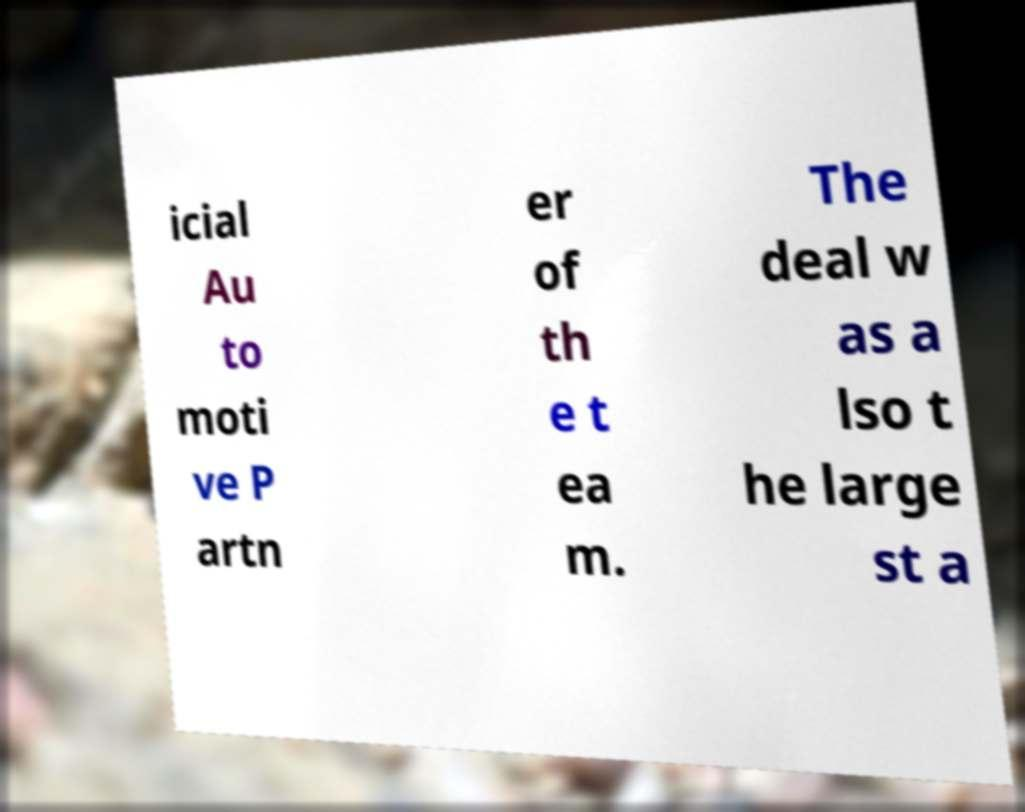Can you accurately transcribe the text from the provided image for me? icial Au to moti ve P artn er of th e t ea m. The deal w as a lso t he large st a 